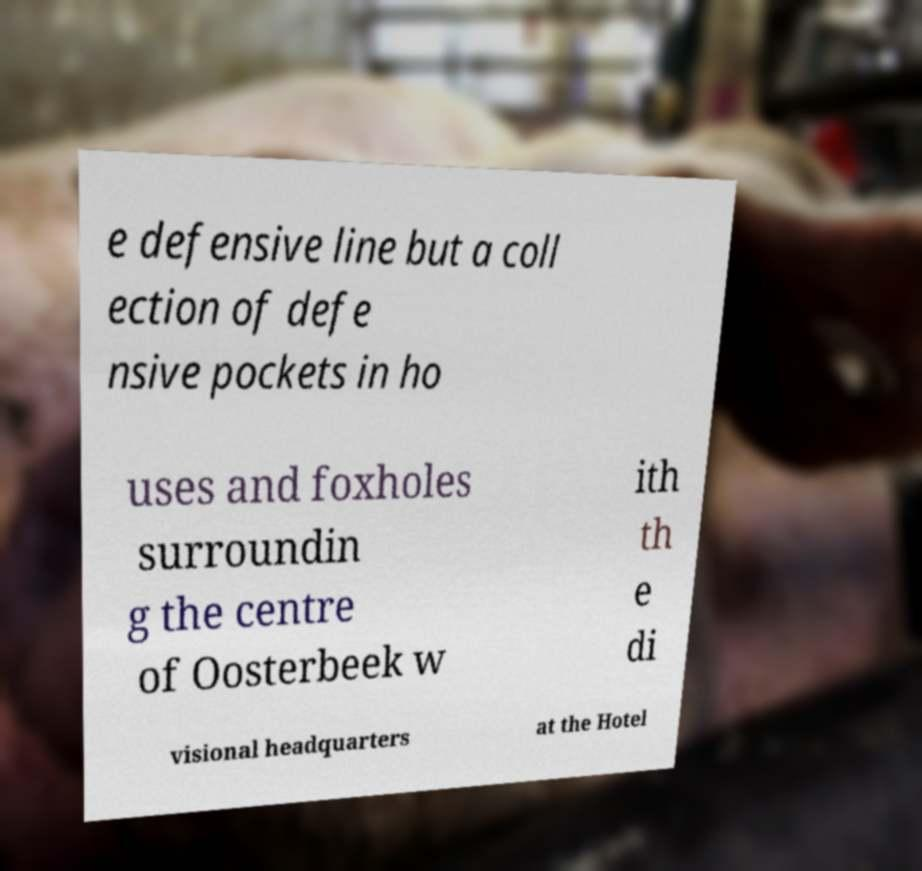Could you extract and type out the text from this image? e defensive line but a coll ection of defe nsive pockets in ho uses and foxholes surroundin g the centre of Oosterbeek w ith th e di visional headquarters at the Hotel 